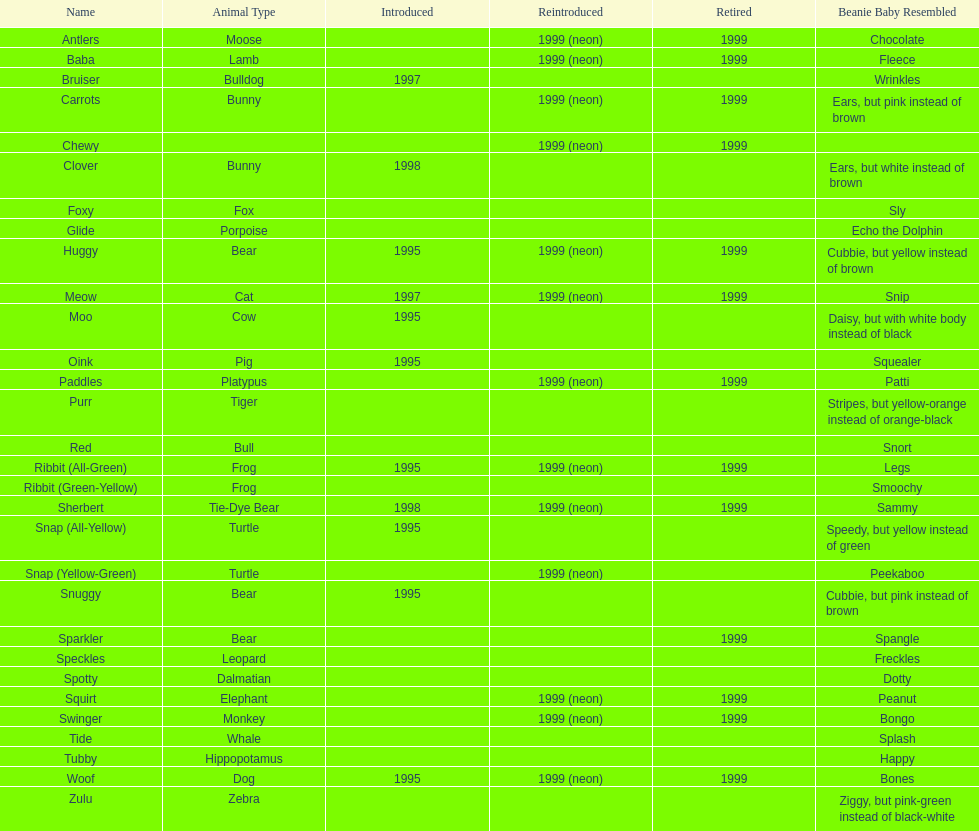What are the types of pillow pal animals? Antlers, Moose, Lamb, Bulldog, Bunny, , Bunny, Fox, Porpoise, Bear, Cat, Cow, Pig, Platypus, Tiger, Bull, Frog, Frog, Tie-Dye Bear, Turtle, Turtle, Bear, Bear, Leopard, Dalmatian, Elephant, Monkey, Whale, Hippopotamus, Dog, Zebra. Of those, which is a dalmatian? Dalmatian. What is the name of the dalmatian? Spotty. 